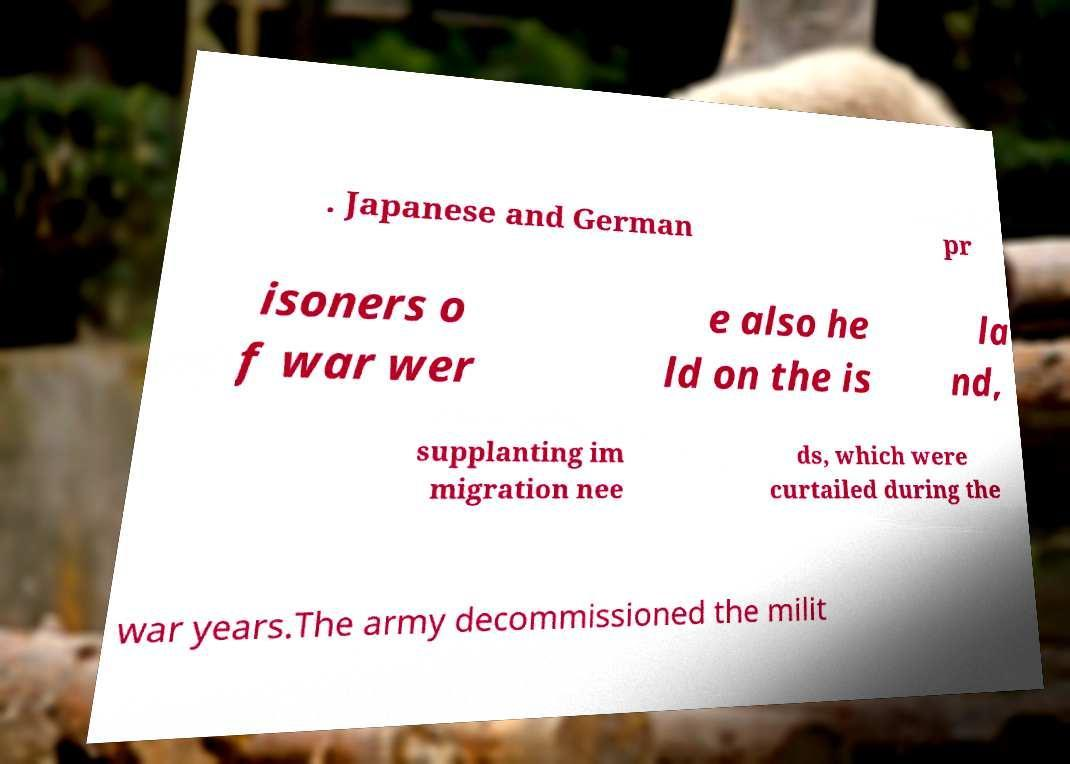Can you accurately transcribe the text from the provided image for me? . Japanese and German pr isoners o f war wer e also he ld on the is la nd, supplanting im migration nee ds, which were curtailed during the war years.The army decommissioned the milit 